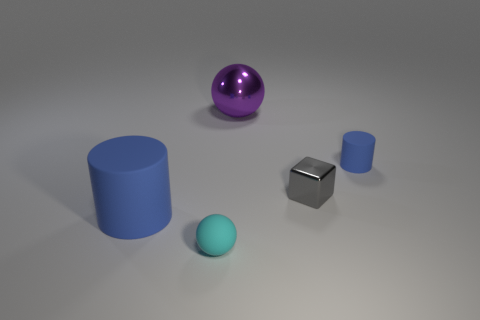What material is the other cylinder that is the same color as the small matte cylinder?
Your answer should be compact. Rubber. What number of matte objects are either gray cubes or tiny red things?
Provide a short and direct response. 0. What shape is the tiny blue object?
Offer a terse response. Cylinder. What number of large blue objects have the same material as the large purple thing?
Give a very brief answer. 0. What is the color of the small cube that is the same material as the purple sphere?
Keep it short and to the point. Gray. Does the blue matte object that is behind the gray metal cube have the same size as the tiny cyan sphere?
Provide a succinct answer. Yes. What color is the other small matte object that is the same shape as the purple thing?
Your answer should be very brief. Cyan. What shape is the big object that is on the left side of the rubber thing that is in front of the cylinder that is in front of the metal block?
Your response must be concise. Cylinder. Is the shape of the small shiny object the same as the small blue matte thing?
Offer a very short reply. No. What shape is the small object on the right side of the metallic thing in front of the small blue object?
Make the answer very short. Cylinder. 